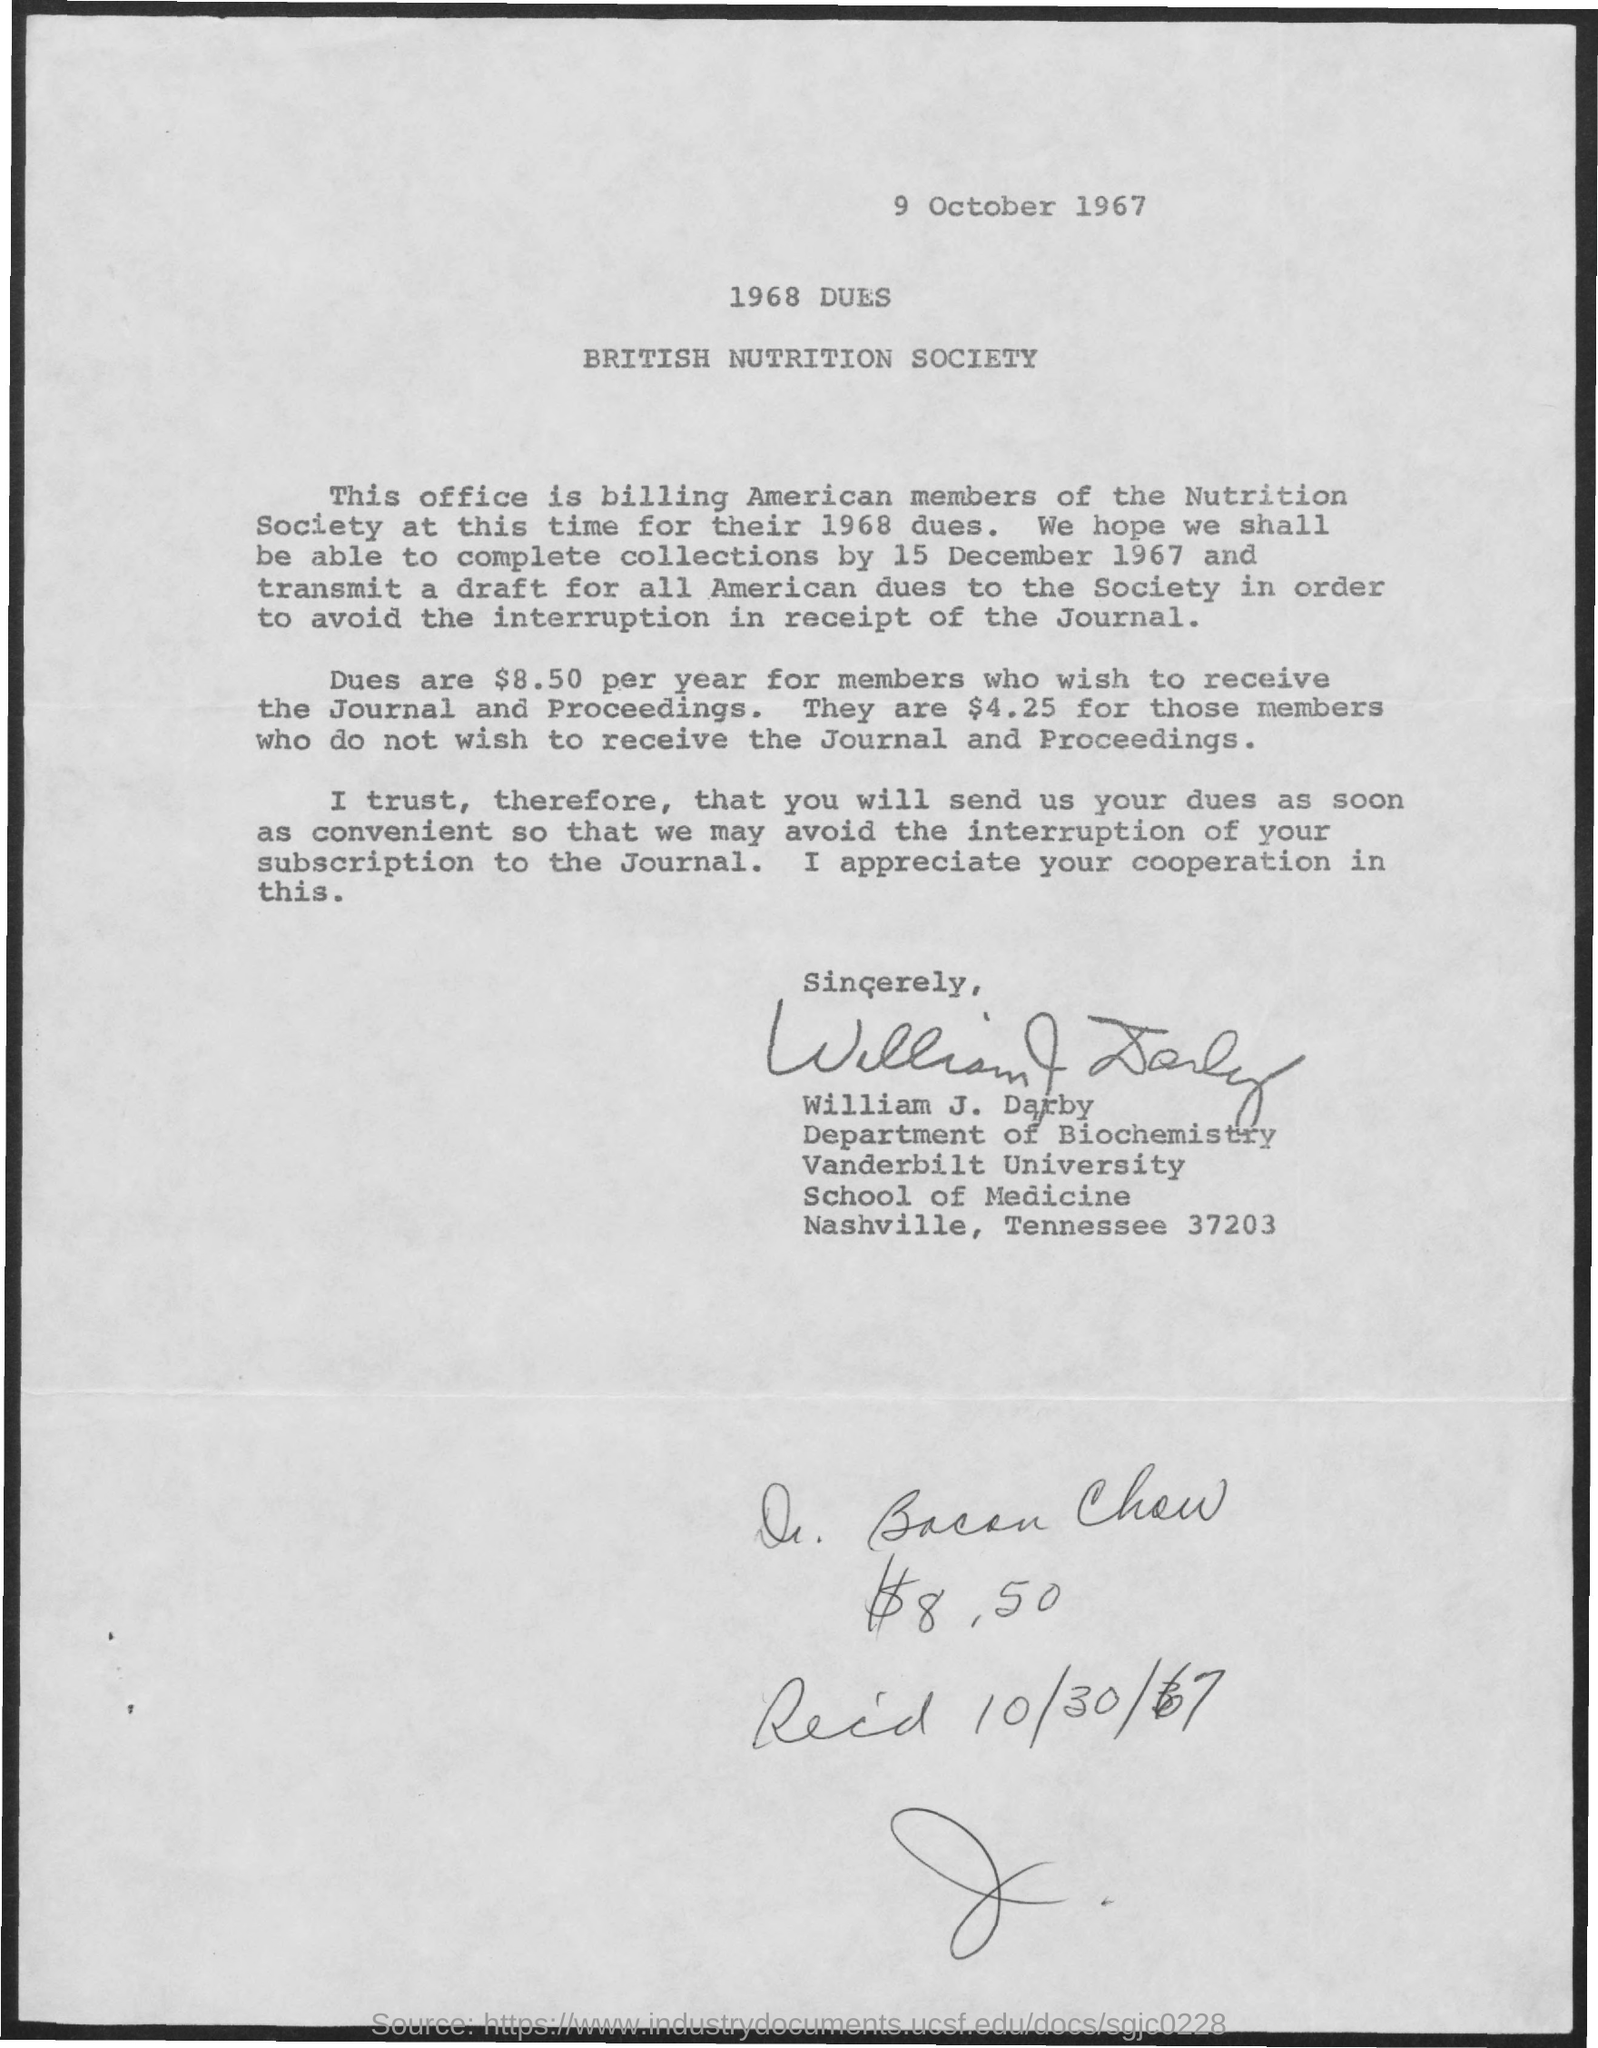What is the date mentioned in the top of the document?
Ensure brevity in your answer.  9 october 1967. 